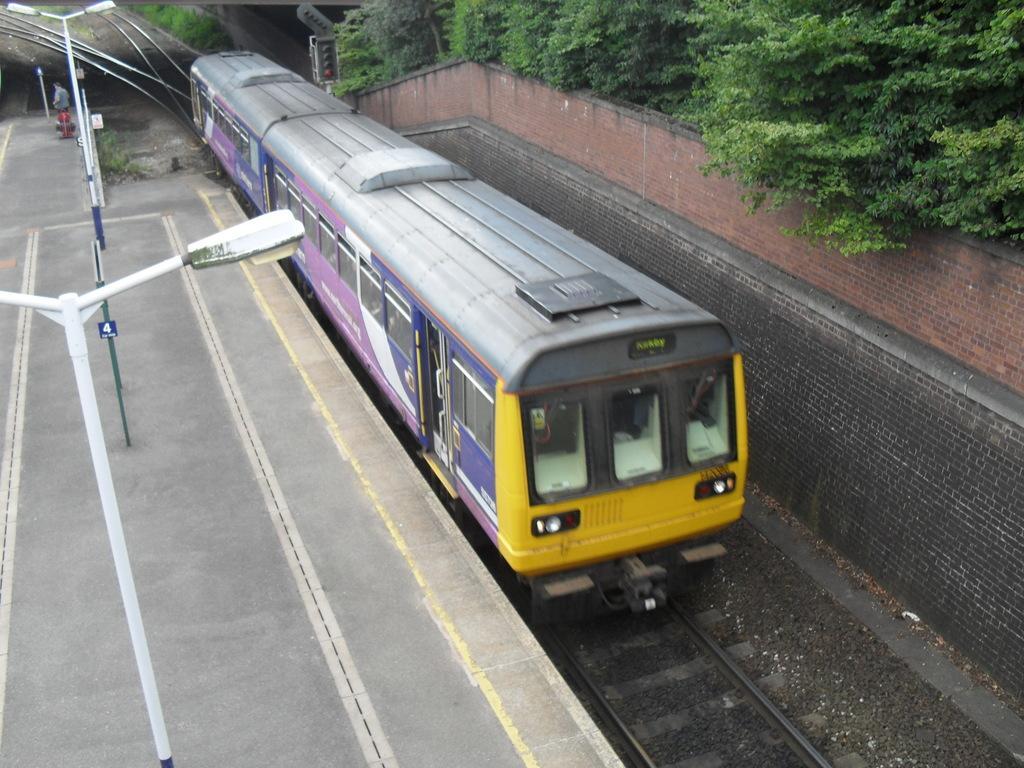Could you give a brief overview of what you see in this image? In the picture we can see a train on the track and beside it, we the platform and on it we can see the poles with lights and on the other side of the train we can see the wall and behind it we can see the trees. 